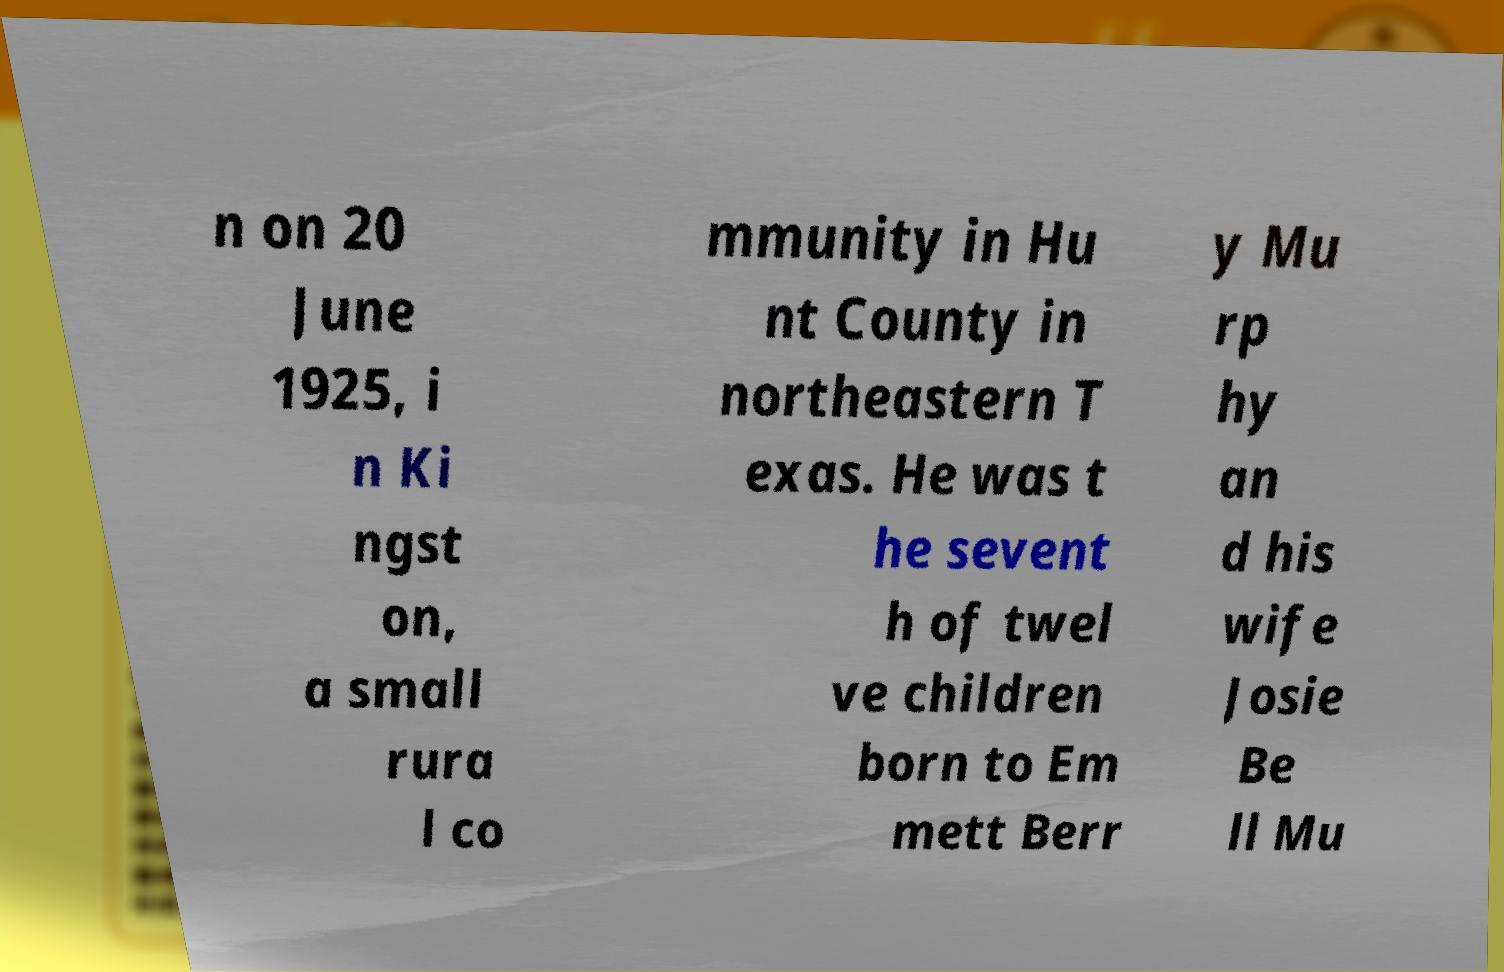What messages or text are displayed in this image? I need them in a readable, typed format. n on 20 June 1925, i n Ki ngst on, a small rura l co mmunity in Hu nt County in northeastern T exas. He was t he sevent h of twel ve children born to Em mett Berr y Mu rp hy an d his wife Josie Be ll Mu 